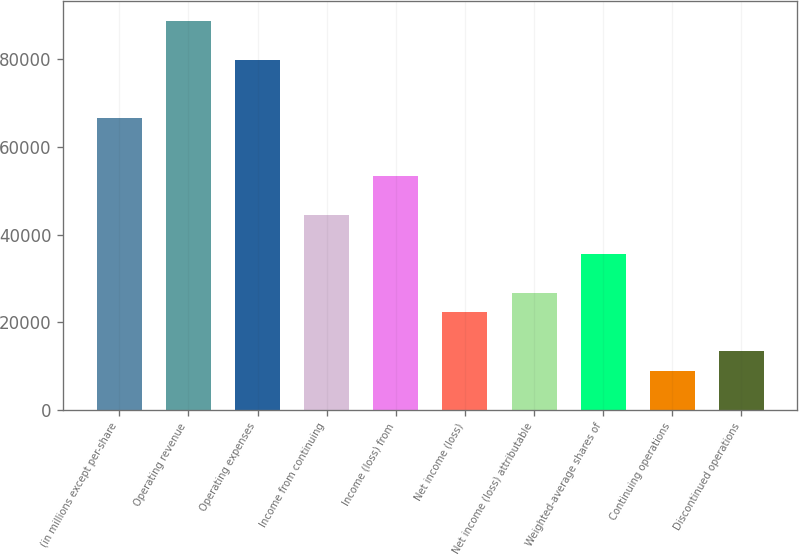Convert chart to OTSL. <chart><loc_0><loc_0><loc_500><loc_500><bar_chart><fcel>(in millions except per-share<fcel>Operating revenue<fcel>Operating expenses<fcel>Income from continuing<fcel>Income (loss) from<fcel>Net income (loss)<fcel>Net income (loss) attributable<fcel>Weighted-average shares of<fcel>Continuing operations<fcel>Discontinued operations<nl><fcel>66590.7<fcel>88787.4<fcel>79908.7<fcel>44394<fcel>53272.6<fcel>22197.3<fcel>26636.6<fcel>35515.3<fcel>8879.24<fcel>13318.6<nl></chart> 